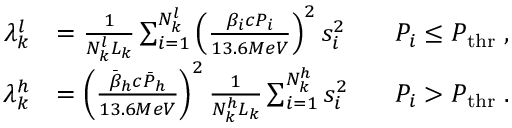<formula> <loc_0><loc_0><loc_500><loc_500>\begin{array} { r l r } { \lambda _ { k } ^ { l } } & { = \frac { 1 } { N _ { k } ^ { l } L _ { k } } \sum _ { i = 1 } ^ { N _ { k } ^ { l } } { \left ( \frac { \beta _ { i } c P _ { i } } { 1 3 . 6 M e V } \right ) ^ { 2 } s _ { i } ^ { 2 } } \, } & { P _ { i } \leq P _ { t h r } \, , } \\ { \lambda _ { k } ^ { h } } & { = \left ( \frac { \bar { \beta } _ { h } c \bar { P } _ { h } } { 1 3 . 6 M e V } \right ) ^ { 2 } \frac { 1 } { N _ { k } ^ { h } L _ { k } } \sum _ { i = 1 } ^ { N _ { k } ^ { h } } { s _ { i } ^ { 2 } } \, } & { P _ { i } > P _ { t h r } \, . } \end{array}</formula> 